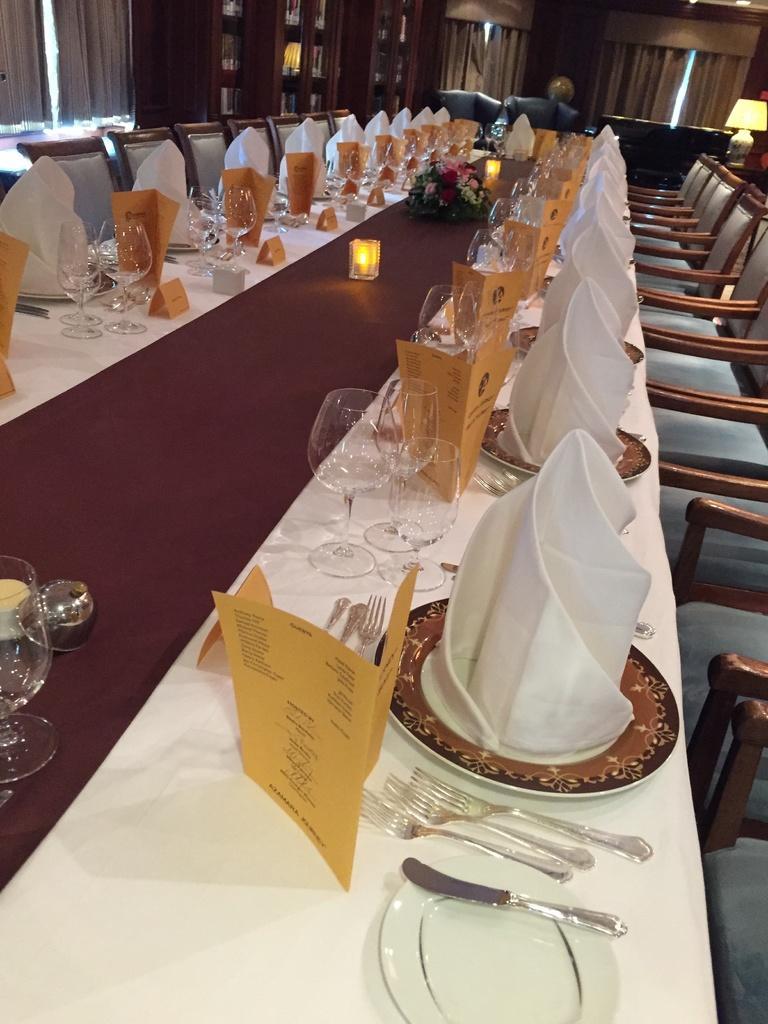How would you summarize this image in a sentence or two? In this image I can see number of chairs and a table. On this table I can see menu cards, number of spoons, glasses, plates and towels. 